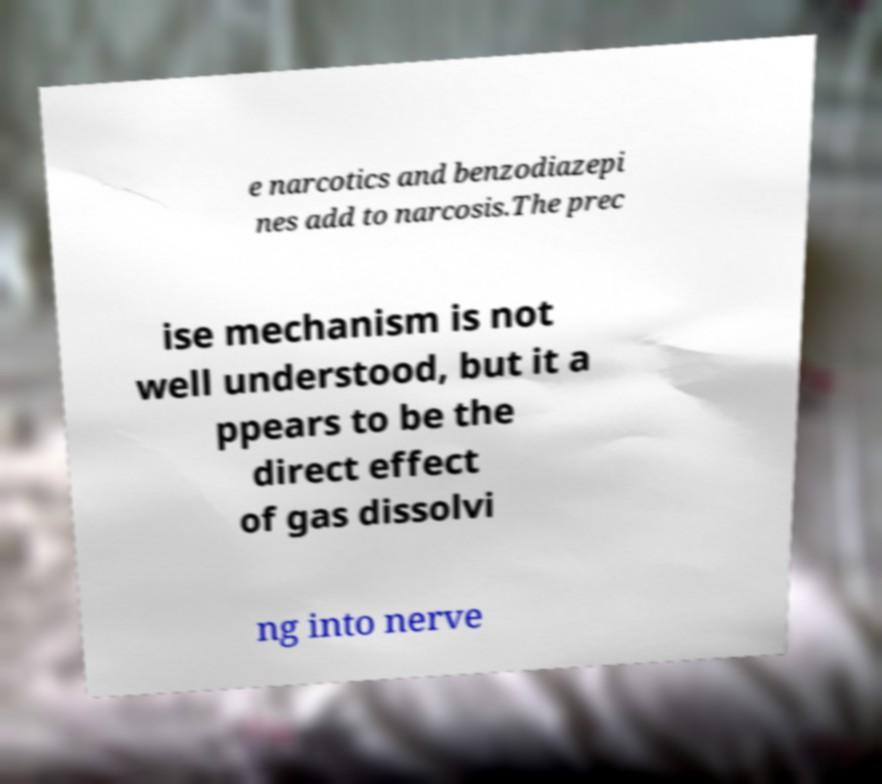Please identify and transcribe the text found in this image. e narcotics and benzodiazepi nes add to narcosis.The prec ise mechanism is not well understood, but it a ppears to be the direct effect of gas dissolvi ng into nerve 